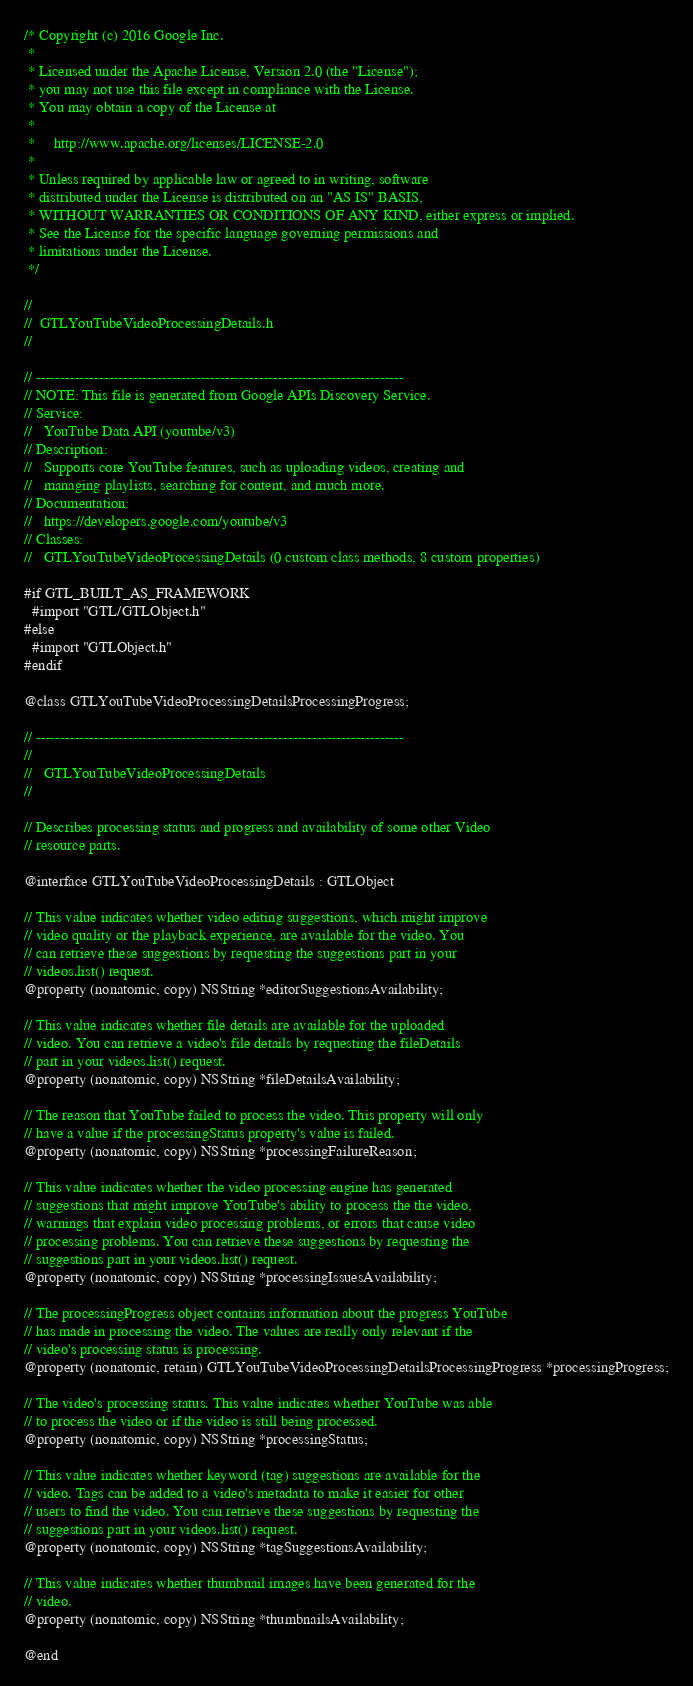<code> <loc_0><loc_0><loc_500><loc_500><_C_>/* Copyright (c) 2016 Google Inc.
 *
 * Licensed under the Apache License, Version 2.0 (the "License");
 * you may not use this file except in compliance with the License.
 * You may obtain a copy of the License at
 *
 *     http://www.apache.org/licenses/LICENSE-2.0
 *
 * Unless required by applicable law or agreed to in writing, software
 * distributed under the License is distributed on an "AS IS" BASIS,
 * WITHOUT WARRANTIES OR CONDITIONS OF ANY KIND, either express or implied.
 * See the License for the specific language governing permissions and
 * limitations under the License.
 */

//
//  GTLYouTubeVideoProcessingDetails.h
//

// ----------------------------------------------------------------------------
// NOTE: This file is generated from Google APIs Discovery Service.
// Service:
//   YouTube Data API (youtube/v3)
// Description:
//   Supports core YouTube features, such as uploading videos, creating and
//   managing playlists, searching for content, and much more.
// Documentation:
//   https://developers.google.com/youtube/v3
// Classes:
//   GTLYouTubeVideoProcessingDetails (0 custom class methods, 8 custom properties)

#if GTL_BUILT_AS_FRAMEWORK
  #import "GTL/GTLObject.h"
#else
  #import "GTLObject.h"
#endif

@class GTLYouTubeVideoProcessingDetailsProcessingProgress;

// ----------------------------------------------------------------------------
//
//   GTLYouTubeVideoProcessingDetails
//

// Describes processing status and progress and availability of some other Video
// resource parts.

@interface GTLYouTubeVideoProcessingDetails : GTLObject

// This value indicates whether video editing suggestions, which might improve
// video quality or the playback experience, are available for the video. You
// can retrieve these suggestions by requesting the suggestions part in your
// videos.list() request.
@property (nonatomic, copy) NSString *editorSuggestionsAvailability;

// This value indicates whether file details are available for the uploaded
// video. You can retrieve a video's file details by requesting the fileDetails
// part in your videos.list() request.
@property (nonatomic, copy) NSString *fileDetailsAvailability;

// The reason that YouTube failed to process the video. This property will only
// have a value if the processingStatus property's value is failed.
@property (nonatomic, copy) NSString *processingFailureReason;

// This value indicates whether the video processing engine has generated
// suggestions that might improve YouTube's ability to process the the video,
// warnings that explain video processing problems, or errors that cause video
// processing problems. You can retrieve these suggestions by requesting the
// suggestions part in your videos.list() request.
@property (nonatomic, copy) NSString *processingIssuesAvailability;

// The processingProgress object contains information about the progress YouTube
// has made in processing the video. The values are really only relevant if the
// video's processing status is processing.
@property (nonatomic, retain) GTLYouTubeVideoProcessingDetailsProcessingProgress *processingProgress;

// The video's processing status. This value indicates whether YouTube was able
// to process the video or if the video is still being processed.
@property (nonatomic, copy) NSString *processingStatus;

// This value indicates whether keyword (tag) suggestions are available for the
// video. Tags can be added to a video's metadata to make it easier for other
// users to find the video. You can retrieve these suggestions by requesting the
// suggestions part in your videos.list() request.
@property (nonatomic, copy) NSString *tagSuggestionsAvailability;

// This value indicates whether thumbnail images have been generated for the
// video.
@property (nonatomic, copy) NSString *thumbnailsAvailability;

@end
</code> 